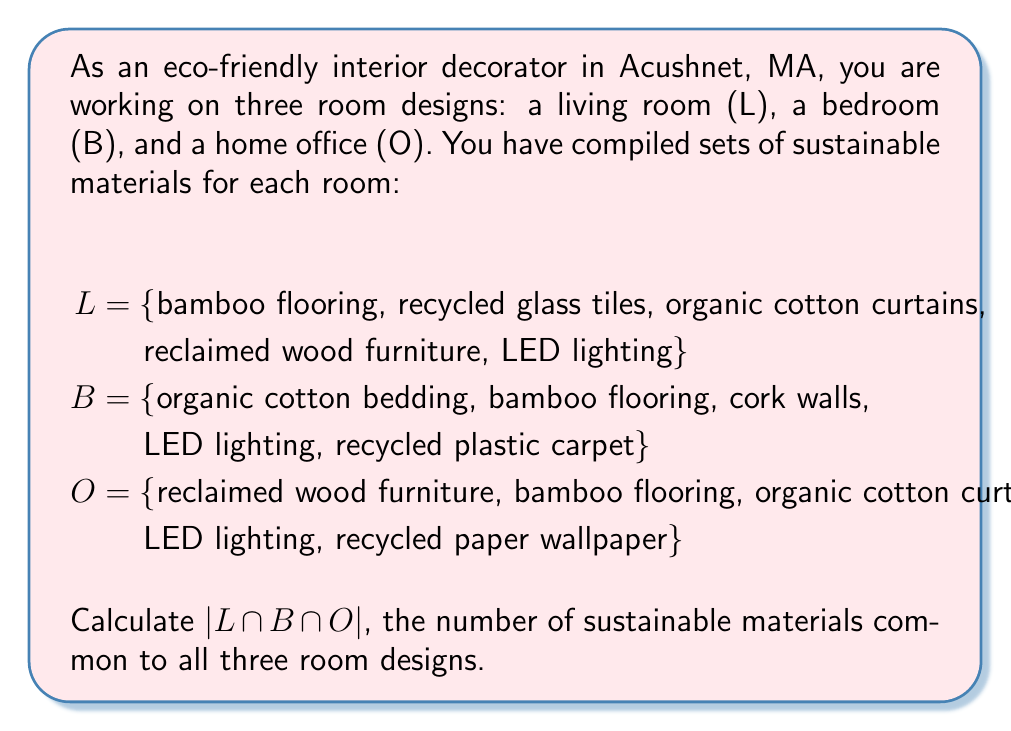Teach me how to tackle this problem. To solve this problem, we need to find the intersection of all three sets and then determine its cardinality (number of elements). Let's approach this step-by-step:

1. First, let's identify the elements that appear in all three sets:

   L = {bamboo flooring, recycled glass tiles, organic cotton curtains, reclaimed wood furniture, LED lighting}
   B = {organic cotton bedding, bamboo flooring, cork walls, LED lighting, recycled plastic carpet}
   O = {reclaimed wood furniture, bamboo flooring, organic cotton curtains, LED lighting, recycled paper wallpaper}

2. The intersection of these sets, denoted as $L \cap B \cap O$, will contain only the elements that are present in all three sets.

3. Examining the sets, we can see that:
   - "bamboo flooring" is in all three sets
   - "LED lighting" is in all three sets

4. No other elements appear in all three sets simultaneously.

5. Therefore, $L \cap B \cap O = \{bamboo flooring, LED lighting\}$

6. The cardinality of this intersection, denoted as $|L \cap B \cap O|$, is the number of elements in this set.

7. Counting the elements, we find that $|L \cap B \cap O| = 2$

Thus, there are 2 sustainable materials common to all three room designs.
Answer: $|L \cap B \cap O| = 2$ 